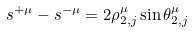Convert formula to latex. <formula><loc_0><loc_0><loc_500><loc_500>s ^ { + \mu } - s ^ { - \mu } = 2 \rho ^ { \mu } _ { 2 , j } \sin \theta ^ { \mu } _ { 2 , j }</formula> 